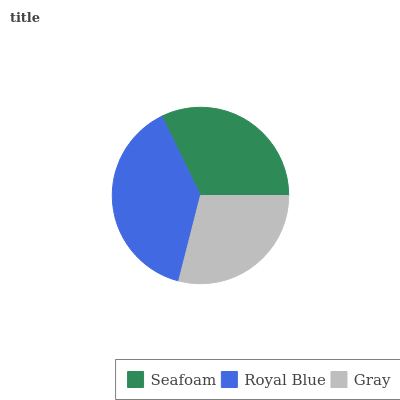Is Gray the minimum?
Answer yes or no. Yes. Is Royal Blue the maximum?
Answer yes or no. Yes. Is Royal Blue the minimum?
Answer yes or no. No. Is Gray the maximum?
Answer yes or no. No. Is Royal Blue greater than Gray?
Answer yes or no. Yes. Is Gray less than Royal Blue?
Answer yes or no. Yes. Is Gray greater than Royal Blue?
Answer yes or no. No. Is Royal Blue less than Gray?
Answer yes or no. No. Is Seafoam the high median?
Answer yes or no. Yes. Is Seafoam the low median?
Answer yes or no. Yes. Is Gray the high median?
Answer yes or no. No. Is Royal Blue the low median?
Answer yes or no. No. 